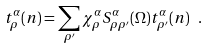<formula> <loc_0><loc_0><loc_500><loc_500>t _ { \rho } ^ { \alpha } ( n ) = \sum _ { \rho ^ { \prime } } \chi _ { \rho } ^ { \alpha } S _ { \rho \rho ^ { \prime } } ^ { \alpha } ( \Omega ) t _ { \rho ^ { \prime } } ^ { \alpha } ( n ) \ .</formula> 